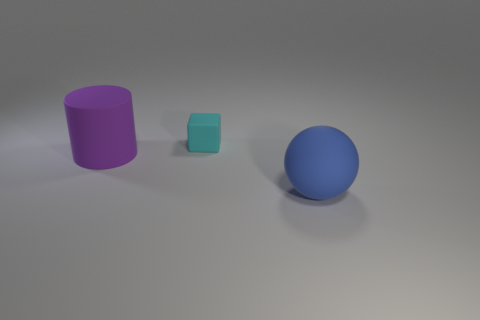Add 1 purple things. How many objects exist? 4 Subtract 1 spheres. How many spheres are left? 0 Subtract all green cylinders. Subtract all green blocks. How many cylinders are left? 1 Subtract all blue matte balls. Subtract all tiny cyan things. How many objects are left? 1 Add 2 rubber cylinders. How many rubber cylinders are left? 3 Add 1 tiny purple blocks. How many tiny purple blocks exist? 1 Subtract 0 brown spheres. How many objects are left? 3 